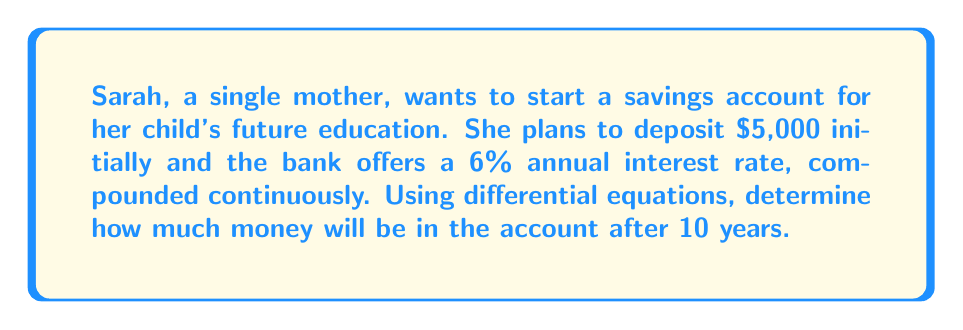Could you help me with this problem? To solve this problem, we'll use the differential equation for continuous compound interest:

$$\frac{dA}{dt} = rA$$

Where:
$A$ is the amount of money in the account
$t$ is time in years
$r$ is the annual interest rate (as a decimal)

1. Set up the initial value problem:
   $$\frac{dA}{dt} = 0.06A$$
   $$A(0) = 5000$$

2. Solve the differential equation:
   $$\frac{dA}{A} = 0.06dt$$
   $$\int \frac{dA}{A} = \int 0.06dt$$
   $$\ln|A| = 0.06t + C$$

3. Apply the initial condition:
   $$\ln|5000| = 0.06(0) + C$$
   $$C = \ln|5000|$$

4. Write the general solution:
   $$\ln|A| = 0.06t + \ln|5000|$$
   $$A = 5000e^{0.06t}$$

5. Calculate the amount after 10 years:
   $$A(10) = 5000e^{0.06(10)}$$
   $$A(10) = 5000e^{0.6}$$
   $$A(10) = 5000(1.8221)$$
   $$A(10) = 9110.50$$
Answer: After 10 years, the account will contain $9,110.50. 